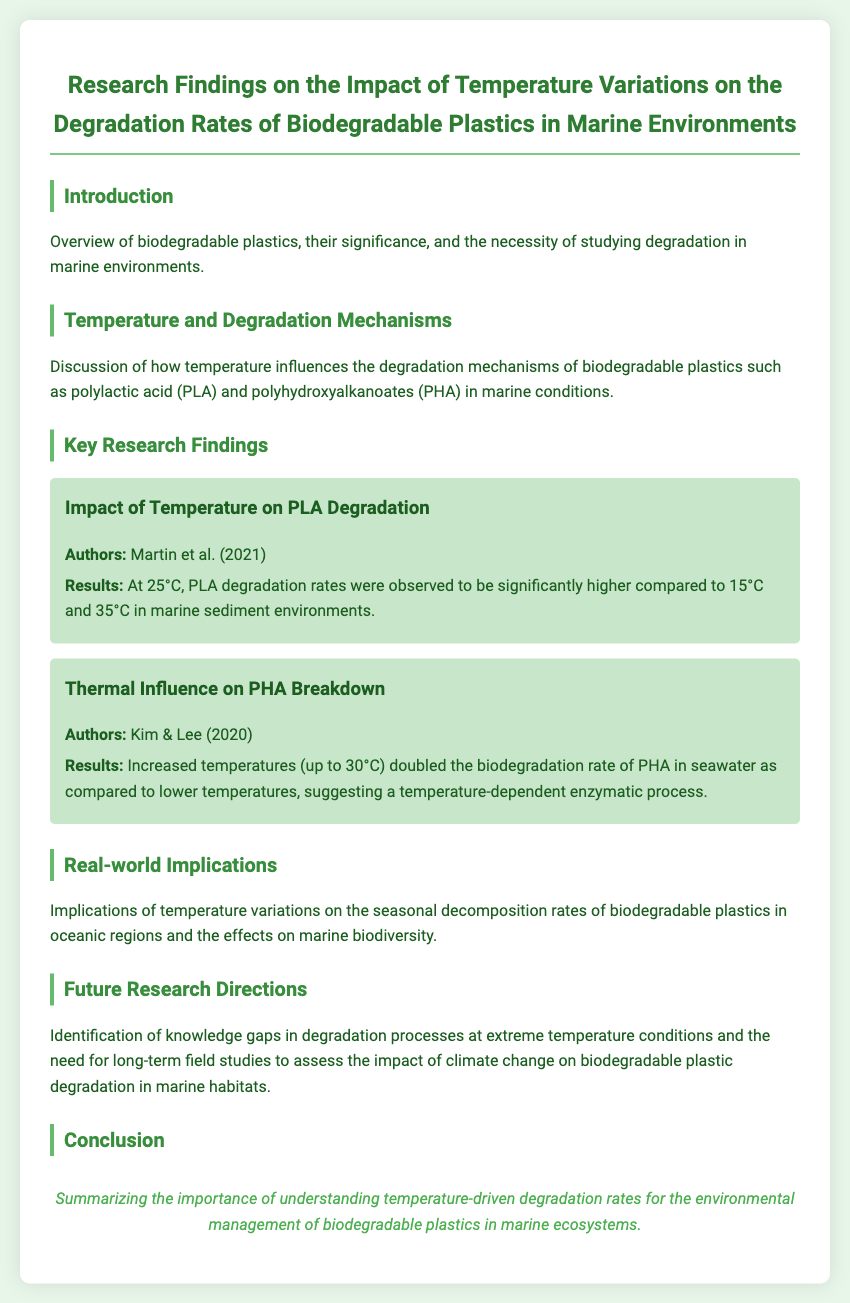What is the title of the document? The title of the document is stated in the header section and reflects the main focus of the research findings.
Answer: Research Findings on the Impact of Temperature Variations on the Degradation Rates of Biodegradable Plastics in Marine Environments Who conducted the study on PLA degradation? The document mentions the authors of the study on PLA degradation, who are credited for their research in this area.
Answer: Martin et al. (2021) What effect does increased temperature have on PHA biodegradation rates? In the section discussing PHA breakdown, it is described how temperature impacts the biodegradation rates significantly.
Answer: Doubled What two biodegradable plastics are specifically mentioned? The introduction section lists the types of biodegradable plastics that are the focus of the study.
Answer: PLA and PHA What is the main conclusion of the document? The conclusion summarizes the overall message regarding the importance of temperature on biodegradable plastic degradation, highlighting a core insight.
Answer: Importance of understanding temperature-driven degradation rates What year was the study on PHA conducted? The document specifies the year the PHA study was conducted, as cited in the key research findings.
Answer: 2020 What is the suggested future research direction? The document indicates a specific area of focus for future studies concerning biodegradable plastics and their degradation.
Answer: Long-term field studies At what temperature did PLA degradation rates significantly increase? The study findings indicate a specific temperature threshold that was significant for PLA degradation.
Answer: 25°C 